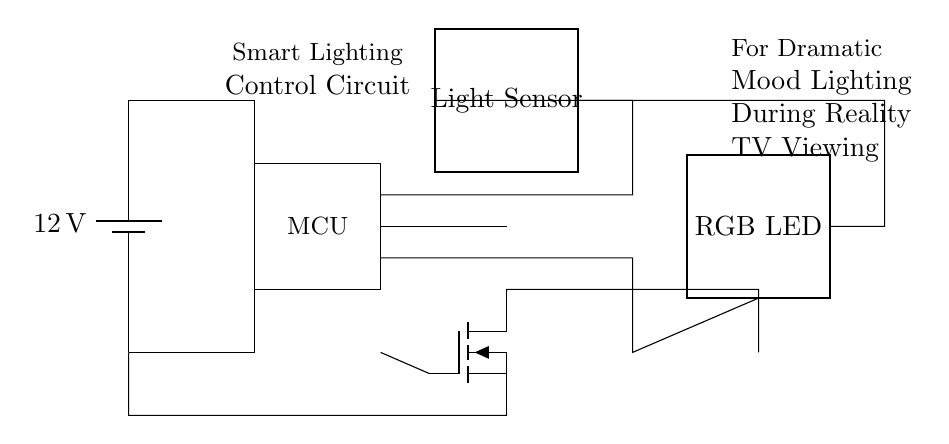What is the voltage of the power supply? The circuit diagram shows a battery labeled with a voltage of twelve volts, which indicates the potential difference provided by the power supply.
Answer: 12 volts What component controls the lighting based on surrounding light conditions? The circuit has a light sensor, which is specifically denoted in the diagram, indicating its function to detect ambient light levels and control the lighting accordingly.
Answer: Light sensor What is the function of the MOSFET in this circuit? The MOSFET (shown in the diagram) is used for dimming the RGB LED. It is connected in such a way that it regulates the current flow to the LED based on the signals received from the MCU.
Answer: Dimming How many main components are there in the circuit diagram? By counting the labeled components in the diagram—one battery, one microcontroller, one light sensor, one RGB LED, and one MOSFET—we determine that there are five distinct main components in total.
Answer: Five What type of LED is used in this circuit? The circuit diagram labels the LED as an RGB LED, indicating it is capable of producing various colors by mixing different intensities of red, green, and blue light.
Answer: RGB LED What does the MCU likely process in this circuit? The MCU (microcontroller) is responsible for processing the input from the light sensor and controlling the dimming of the RGB LED, hence it's vital in making lighting adjustments based on the detected ambient light conditions.
Answer: Inputs and outputs 